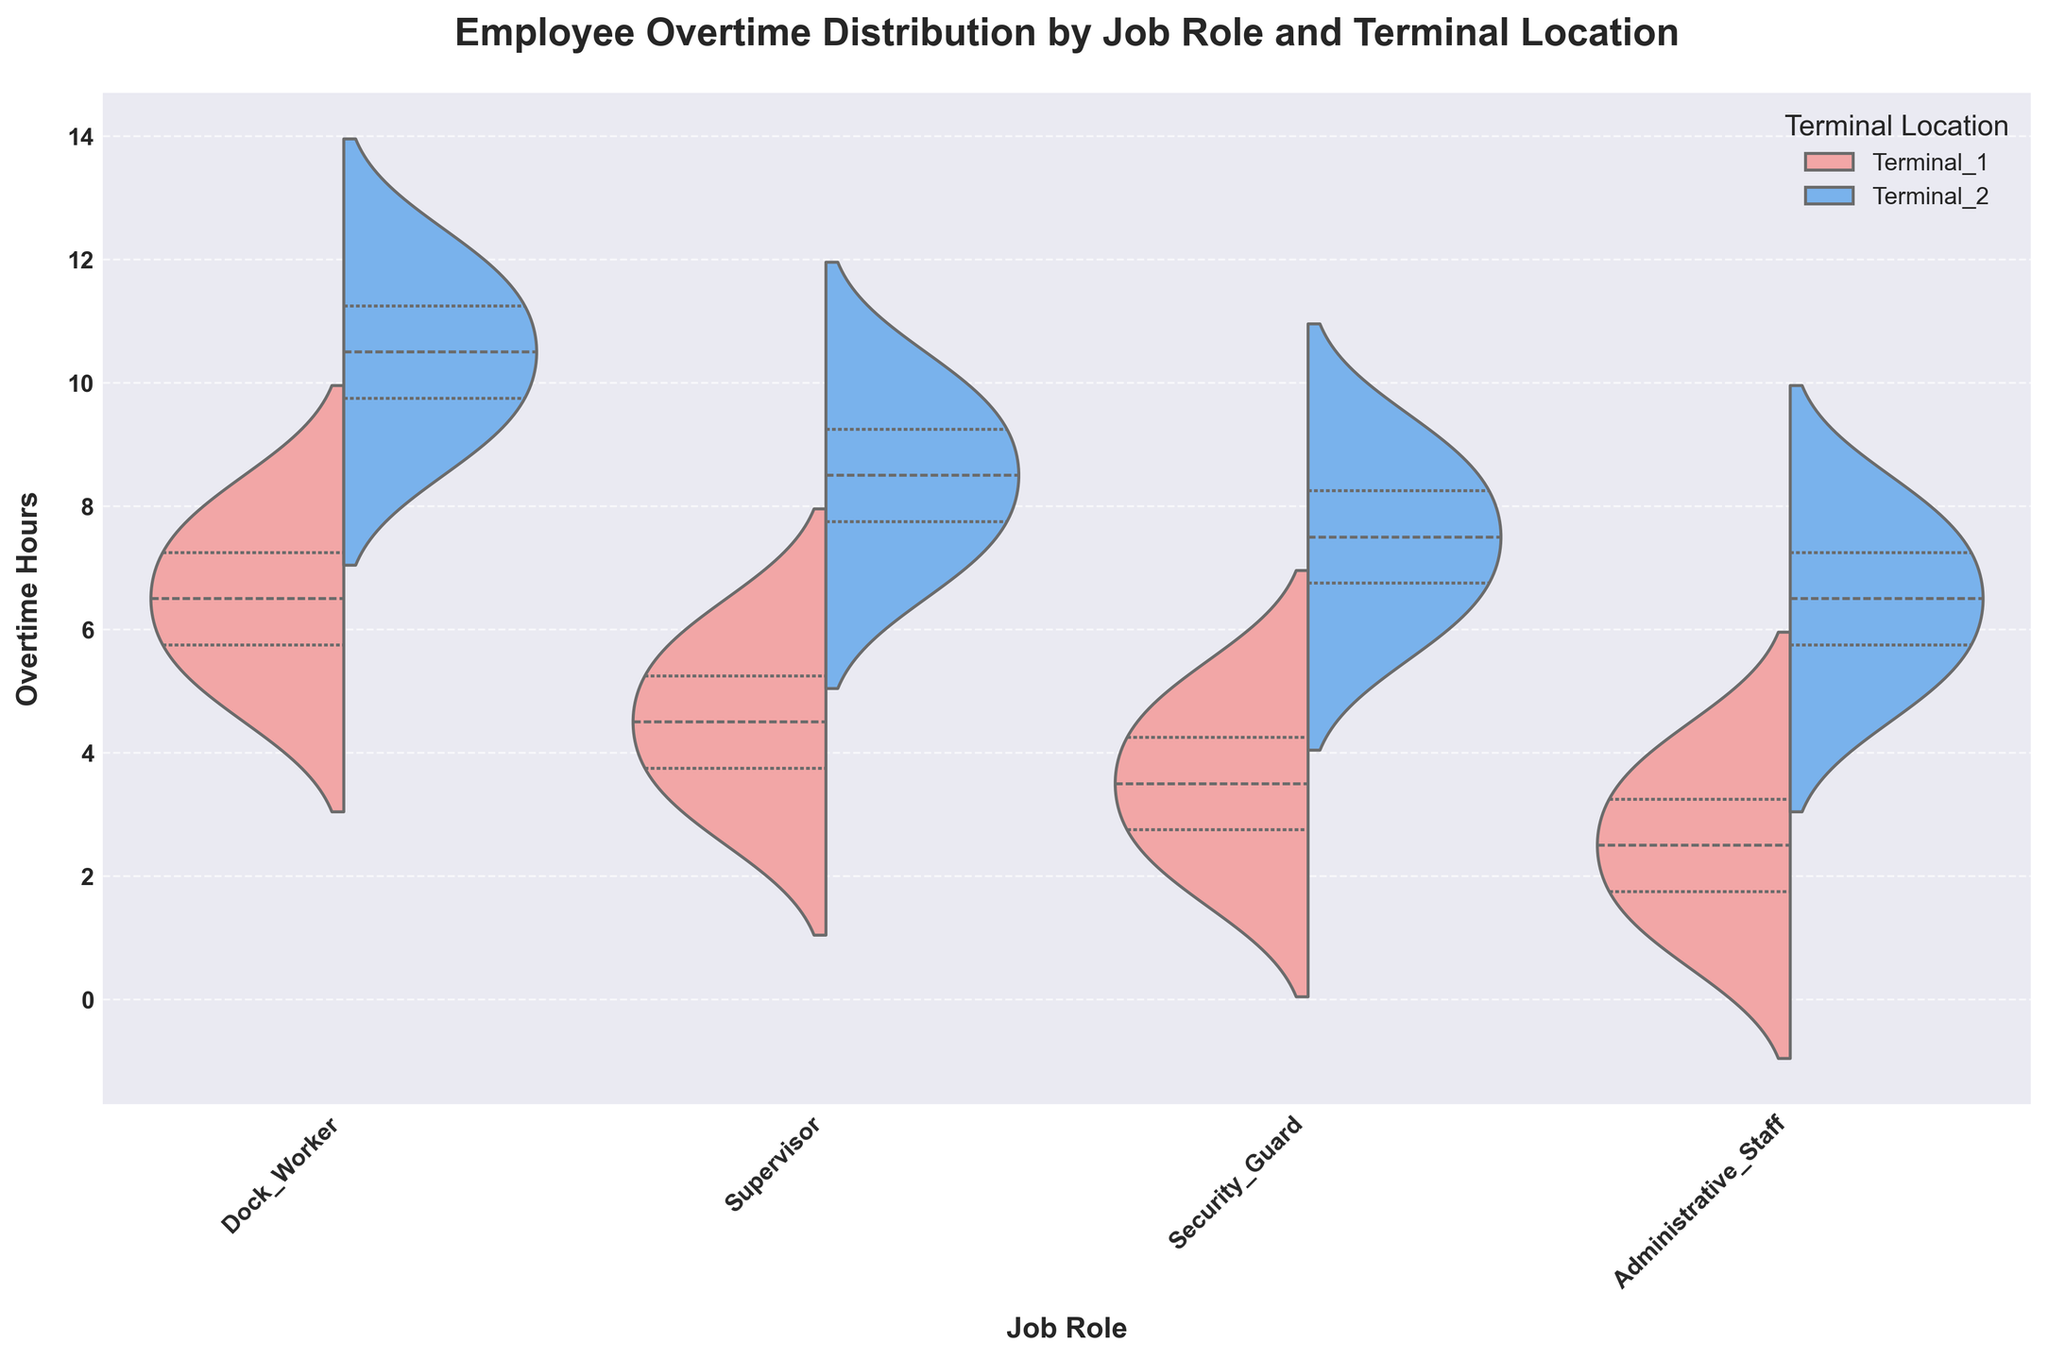What's the title of the chart? The title is found at the top of the chart and provides a summary of what the chart is displaying.
Answer: Employee Overtime Distribution by Job Role and Terminal Location How many job roles are displayed in the chart? The job roles can be counted along the x-axis of the chart, where each unique label represents a different job role.
Answer: Four Which job role at Terminal 2 has the highest maximum overtime hours? By observing the upper extremes of the violin plots, the job role with the highest maximum value for Terminal 2 can be identified.
Answer: Dock Worker What's the median value of overtime hours for Supervisors at Terminal 1? The median values are indicated by the white dot within the violin plot for the specified role and terminal location. For Supervisors at Terminal 1, locate the white dot within the respective section of the violin plot.
Answer: 4.5 hours How do the overtime hour distributions of Security Guards differ between Terminal 1 and Terminal 2? By comparing the two halves of the Security Guard violin plots (one color for each terminal), we can describe differences in spread, central tendencies, and range.
Answer: Terminal 1 has a lower range (2 to 5 hours) while Terminal 2 has a higher range (6 to 9 hours) Which job roles at Terminal 1 have similar overtime hour distributions? Examine the shapes, spreads, and central boxes of the violin plots for all job roles at Terminal 1 to find similarities.
Answer: Security Guard and Administrative Staff What is the interquartile range (IQR) of overtime hours for Dock Workers at Terminal 1? The interquartile range can be found by looking at the spacing between the first (25th percentile) and third (75th percentile) quartiles within the violin plot for Dock Workers at Terminal 1.
Answer: 2 hours Are overtime hours more variable for Dock Workers or Supervisors at Terminal 2? The variability can be assessed by comparing the width and spread of the violin plots for Dock Workers and Supervisors at Terminal 2. The wider and more spread out the plot, the higher the variability.
Answer: Dock Workers Which terminal location, on average, appears to have higher overtime hours for Administrative Staff? Compare the central tendencies (mediants) of the two halves of the Administrative Staff violin plots. Whichever terminal (color) has the higher center indicates a higher average overtime.
Answer: Terminal 2 